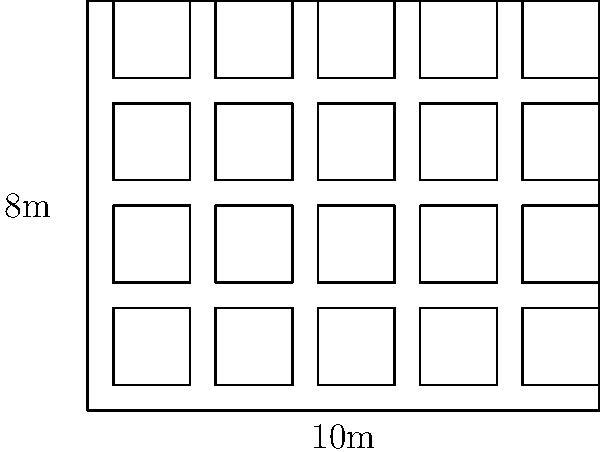You are organizing a meetup event in your co-working space. The main room is rectangular, measuring 10m long and 8m wide. If you use square tables that are 1.5m on each side and maintain a minimum spacing of 0.5m between tables and from the walls, what is the maximum number of tables you can fit in the room? Let's approach this step-by-step:

1) First, we need to calculate the number of tables that can fit along the length and width of the room.

2) For the length (10m):
   - Space needed for each table: 1.5m (table) + 0.5m (spacing) = 2m
   - Available space: 10m - (2 * 0.5m) = 9m (subtracting the spacing from walls)
   - Number of tables along length: $\lfloor 9 \div 2 \rfloor = 4$ tables

3) For the width (8m):
   - Space needed for each table: 1.5m (table) + 0.5m (spacing) = 2m
   - Available space: 8m - (2 * 0.5m) = 7m (subtracting the spacing from walls)
   - Number of tables along width: $\lfloor 7 \div 2 \rfloor = 3$ tables

4) The total number of tables is the product of tables along length and width:
   $4 * 3 = 12$ tables

Therefore, the maximum number of tables that can fit in the room while maintaining the required spacing is 12.
Answer: 12 tables 